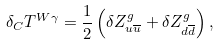Convert formula to latex. <formula><loc_0><loc_0><loc_500><loc_500>\delta _ { C } T ^ { W \gamma } = \frac { 1 } { 2 } \left ( \delta Z _ { u \overline { u } } ^ { g } + \delta Z _ { d \overline { d } } ^ { g } \right ) ,</formula> 